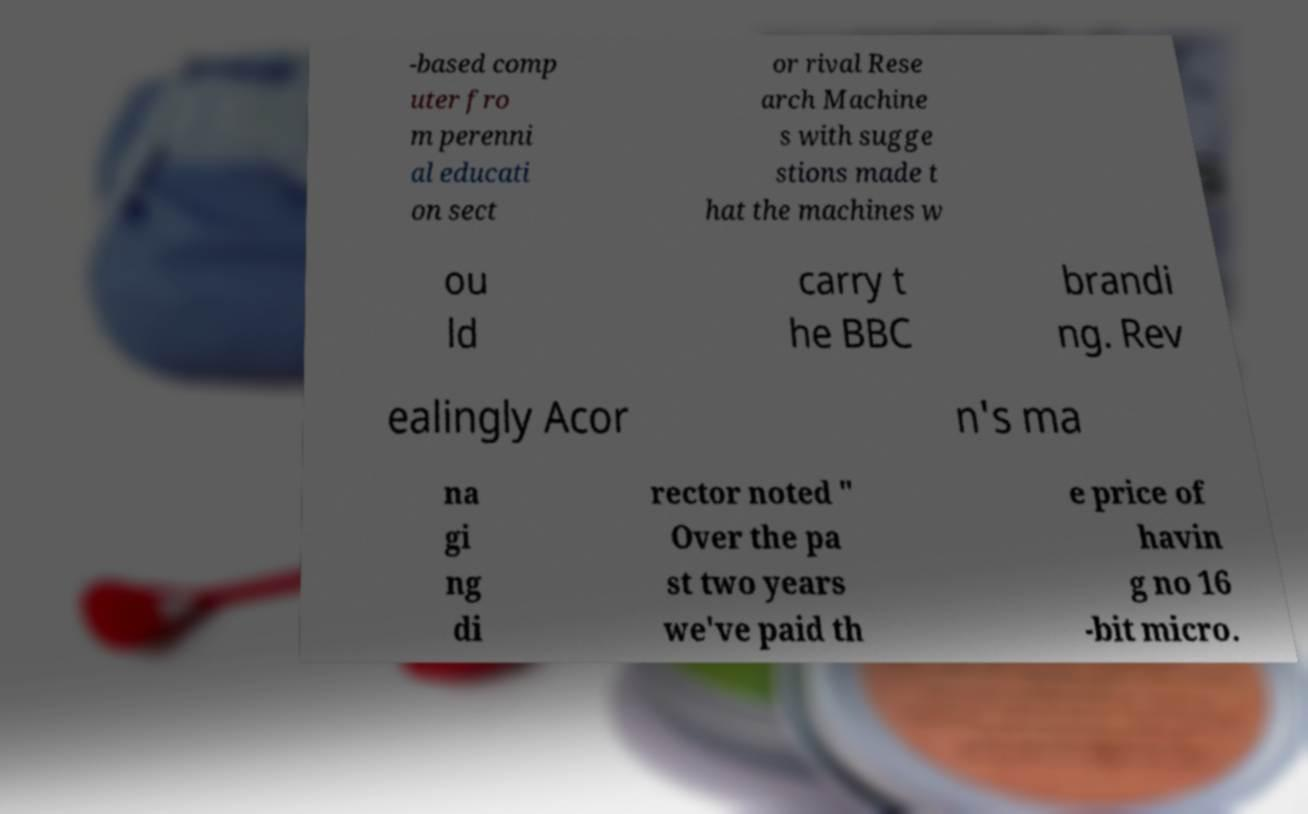Could you assist in decoding the text presented in this image and type it out clearly? -based comp uter fro m perenni al educati on sect or rival Rese arch Machine s with sugge stions made t hat the machines w ou ld carry t he BBC brandi ng. Rev ealingly Acor n's ma na gi ng di rector noted " Over the pa st two years we've paid th e price of havin g no 16 -bit micro. 